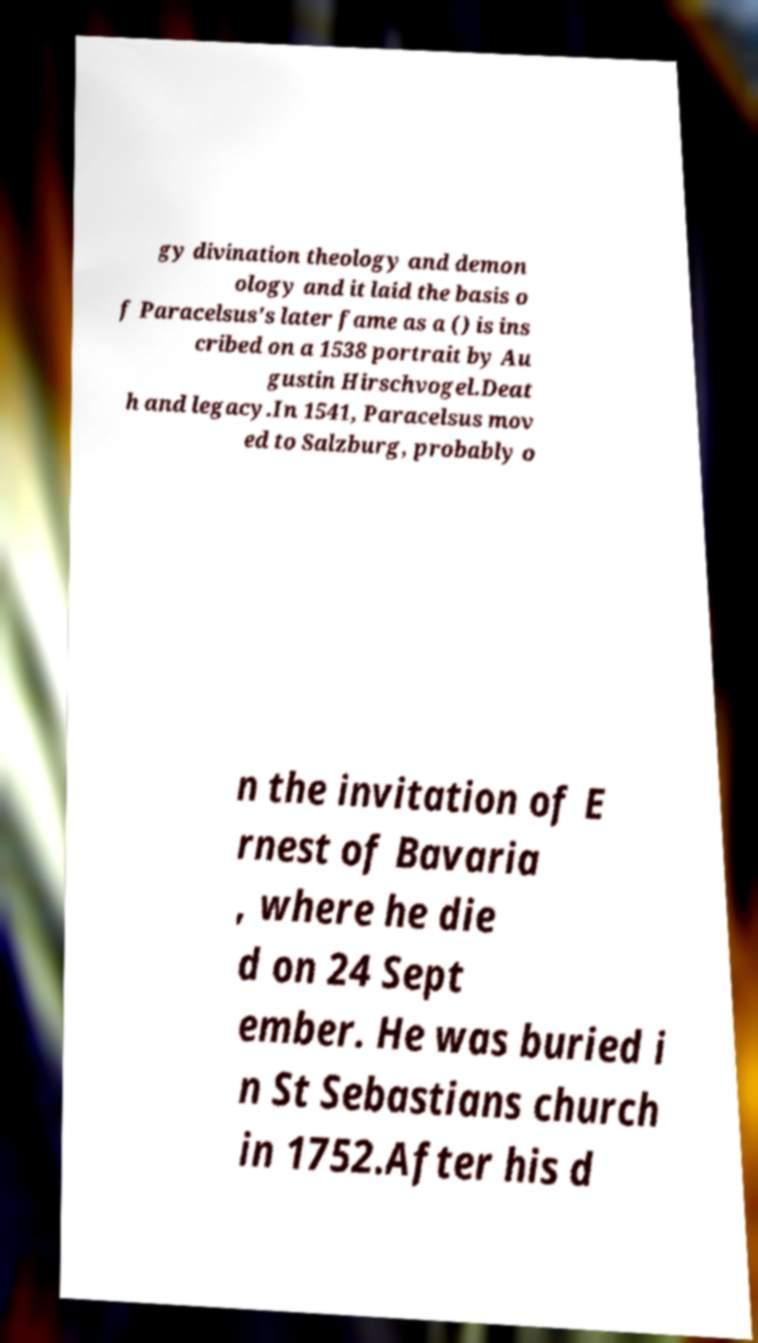Can you read and provide the text displayed in the image?This photo seems to have some interesting text. Can you extract and type it out for me? gy divination theology and demon ology and it laid the basis o f Paracelsus's later fame as a () is ins cribed on a 1538 portrait by Au gustin Hirschvogel.Deat h and legacy.In 1541, Paracelsus mov ed to Salzburg, probably o n the invitation of E rnest of Bavaria , where he die d on 24 Sept ember. He was buried i n St Sebastians church in 1752.After his d 